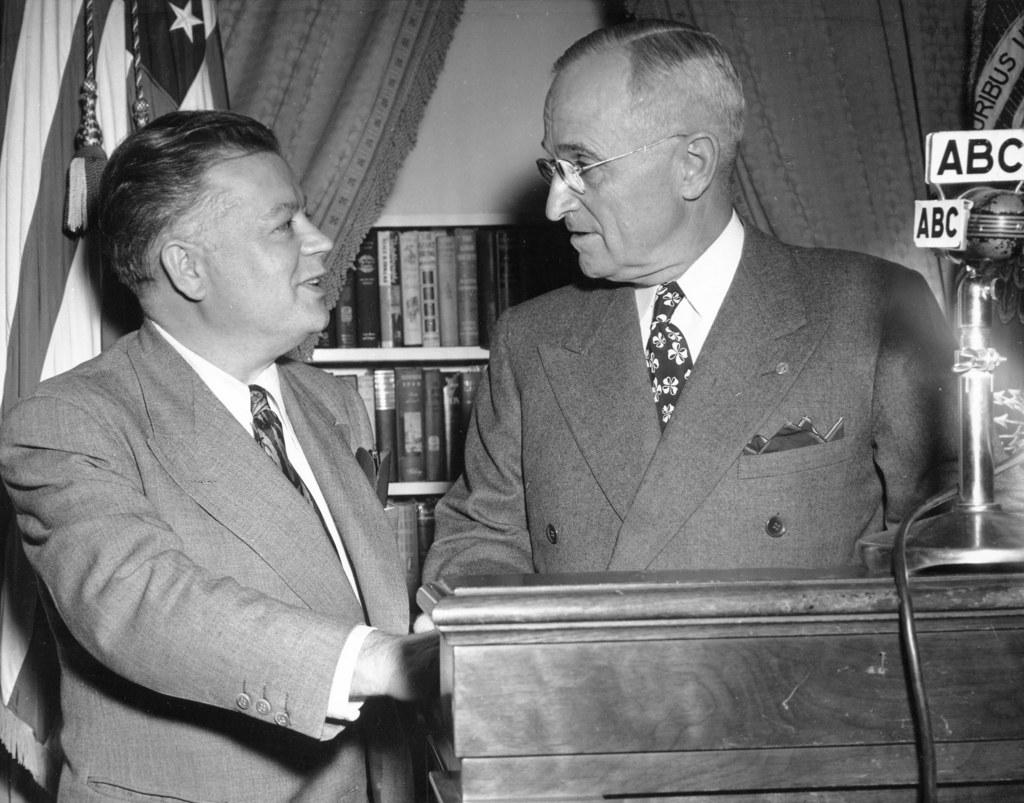Provide a one-sentence caption for the provided image. Someone is speaking to President Harry S. Truman at a podium near a microphone belonging to the ABC network. 